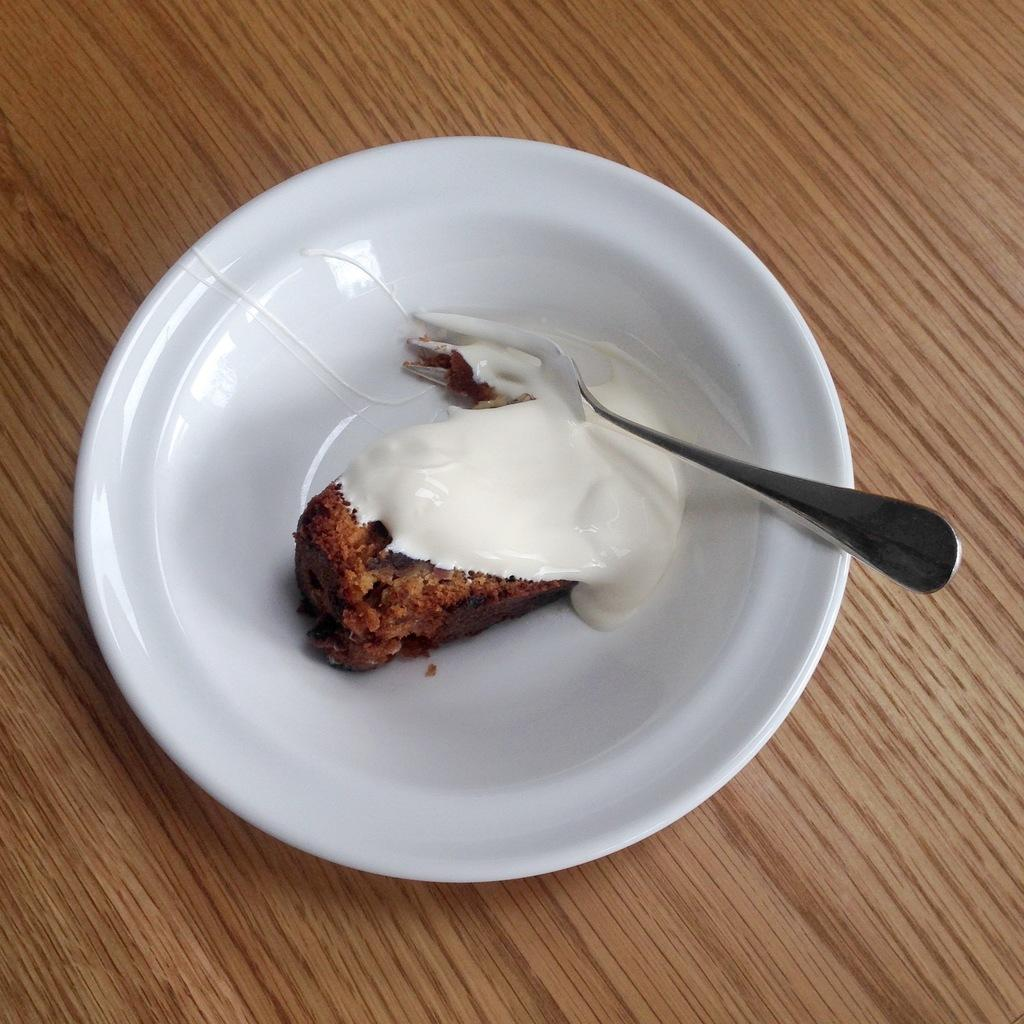What is on the plate that is visible in the image? There is a plate containing dessert in the image. What utensil is placed on the table in the image? There is a fork placed on the table in the image. What type of authority does the tiger have in the image? There is no tiger present in the image, so it is not possible to determine any authority it might have. 